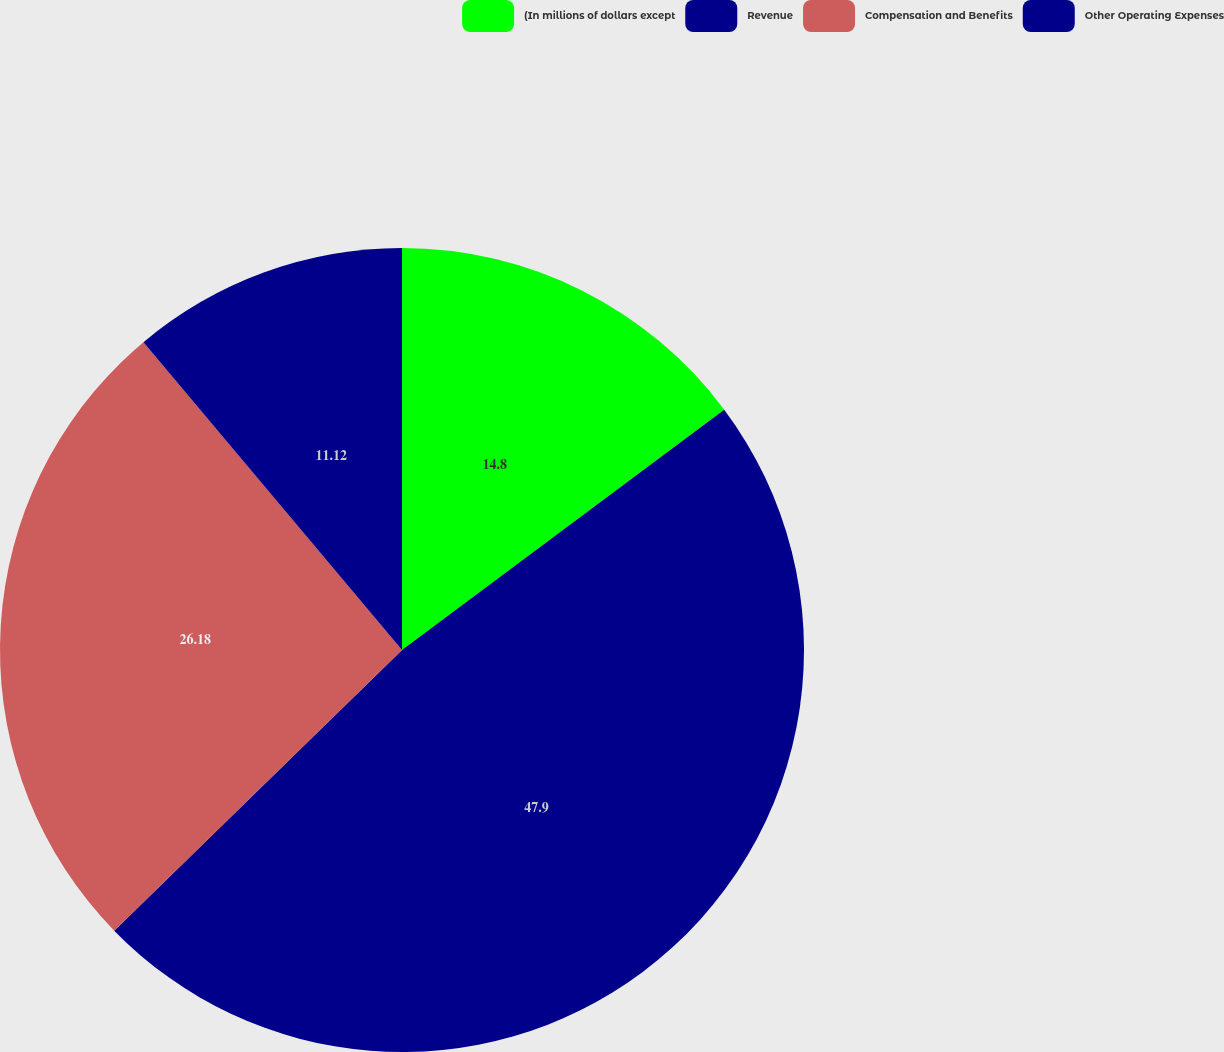Convert chart. <chart><loc_0><loc_0><loc_500><loc_500><pie_chart><fcel>(In millions of dollars except<fcel>Revenue<fcel>Compensation and Benefits<fcel>Other Operating Expenses<nl><fcel>14.8%<fcel>47.9%<fcel>26.18%<fcel>11.12%<nl></chart> 